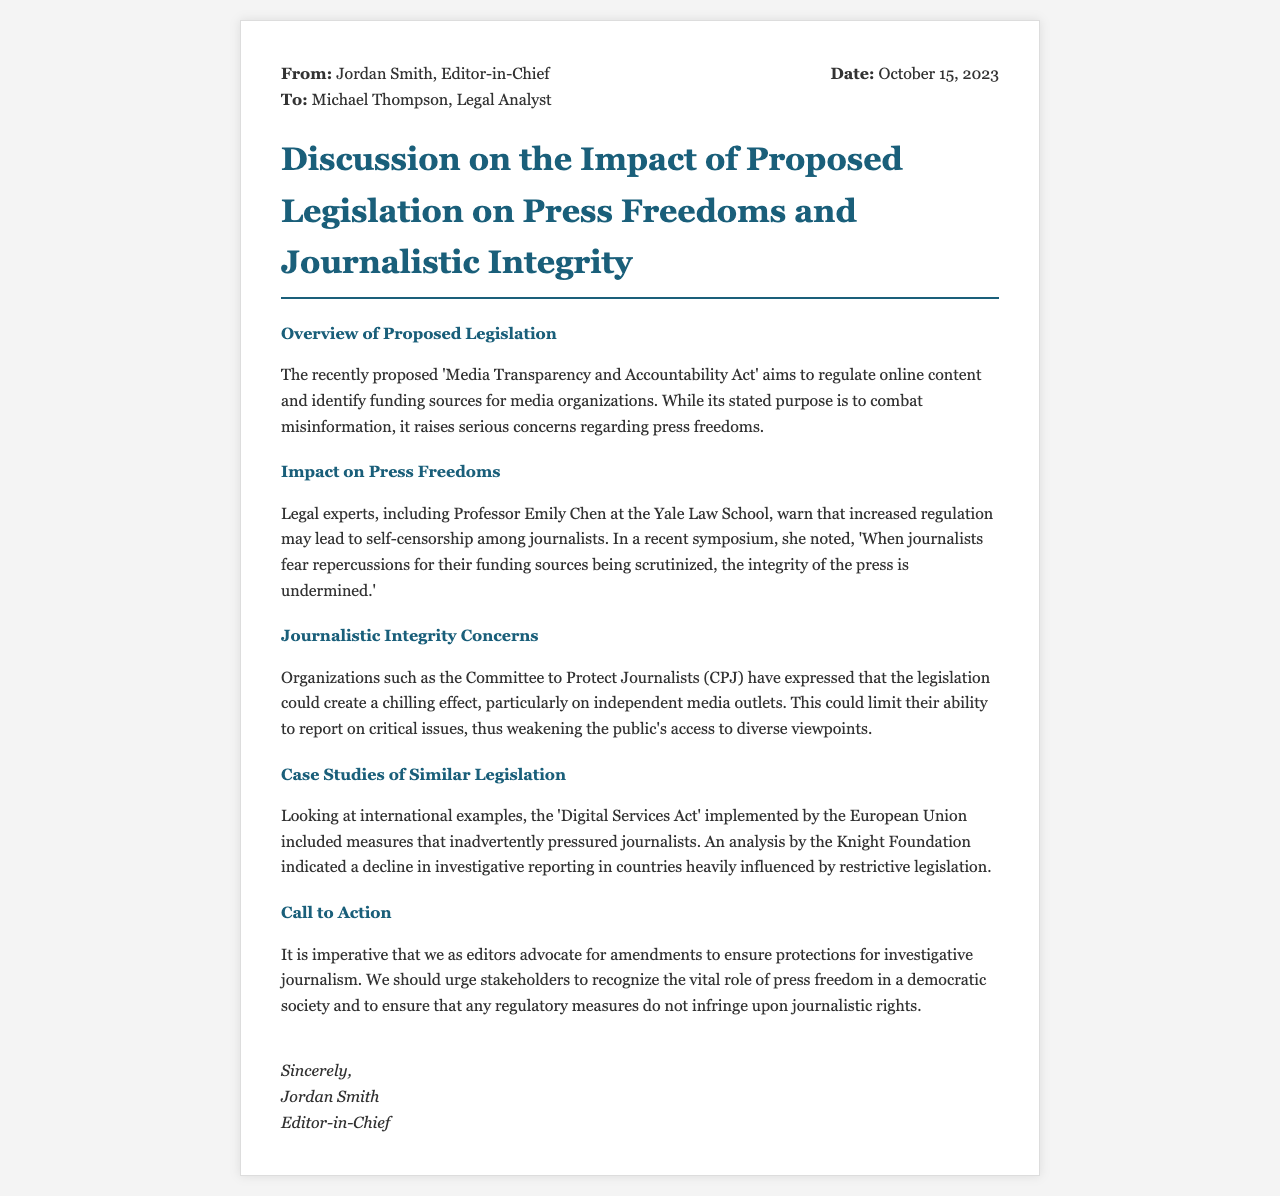What is the name of the legislation being discussed? The document mentions the 'Media Transparency and Accountability Act' as the proposed legislation.
Answer: Media Transparency and Accountability Act Who is the legal expert cited in the letter? Professor Emily Chen from Yale Law School is mentioned as a legal expert.
Answer: Professor Emily Chen What effect does the proposed legislation have on journalists, according to the letter? The letter states that increased regulation may lead to self-censorship among journalists.
Answer: Self-censorship What organization expressed concerns about the legislation's impact on independent media? The Committee to Protect Journalists (CPJ) is noted as expressing concerns regarding the legislation.
Answer: Committee to Protect Journalists What is a key argument made by the Knight Foundation regarding similar legislation? The Knight Foundation's analysis indicated a decline in investigative reporting in countries influenced by restrictive legislation.
Answer: Decline in investigative reporting What is the date on which the letter was written? The letter was dated October 15, 2023.
Answer: October 15, 2023 What is the primary call to action in the letter? The letter urges editors to advocate for amendments to ensure protections for investigative journalism.
Answer: Advocate for amendments Which international legislation is referenced as a case study? The 'Digital Services Act' implemented by the European Union is referenced as a case study.
Answer: Digital Services Act Who is the sender of the letter? The sender of the letter is Jordan Smith, the Editor-in-Chief.
Answer: Jordan Smith 